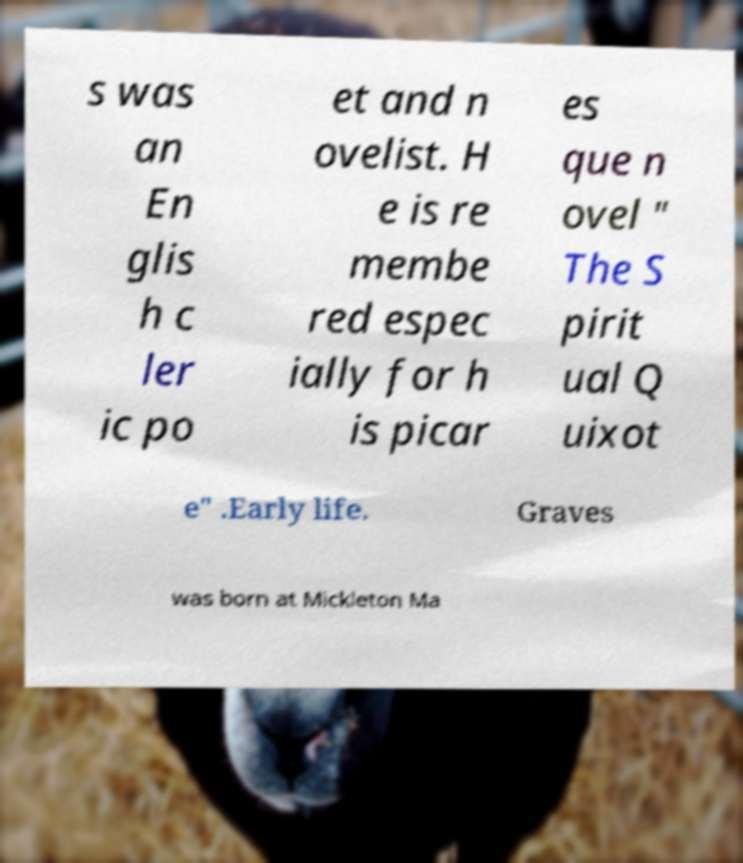Could you assist in decoding the text presented in this image and type it out clearly? s was an En glis h c ler ic po et and n ovelist. H e is re membe red espec ially for h is picar es que n ovel " The S pirit ual Q uixot e" .Early life. Graves was born at Mickleton Ma 